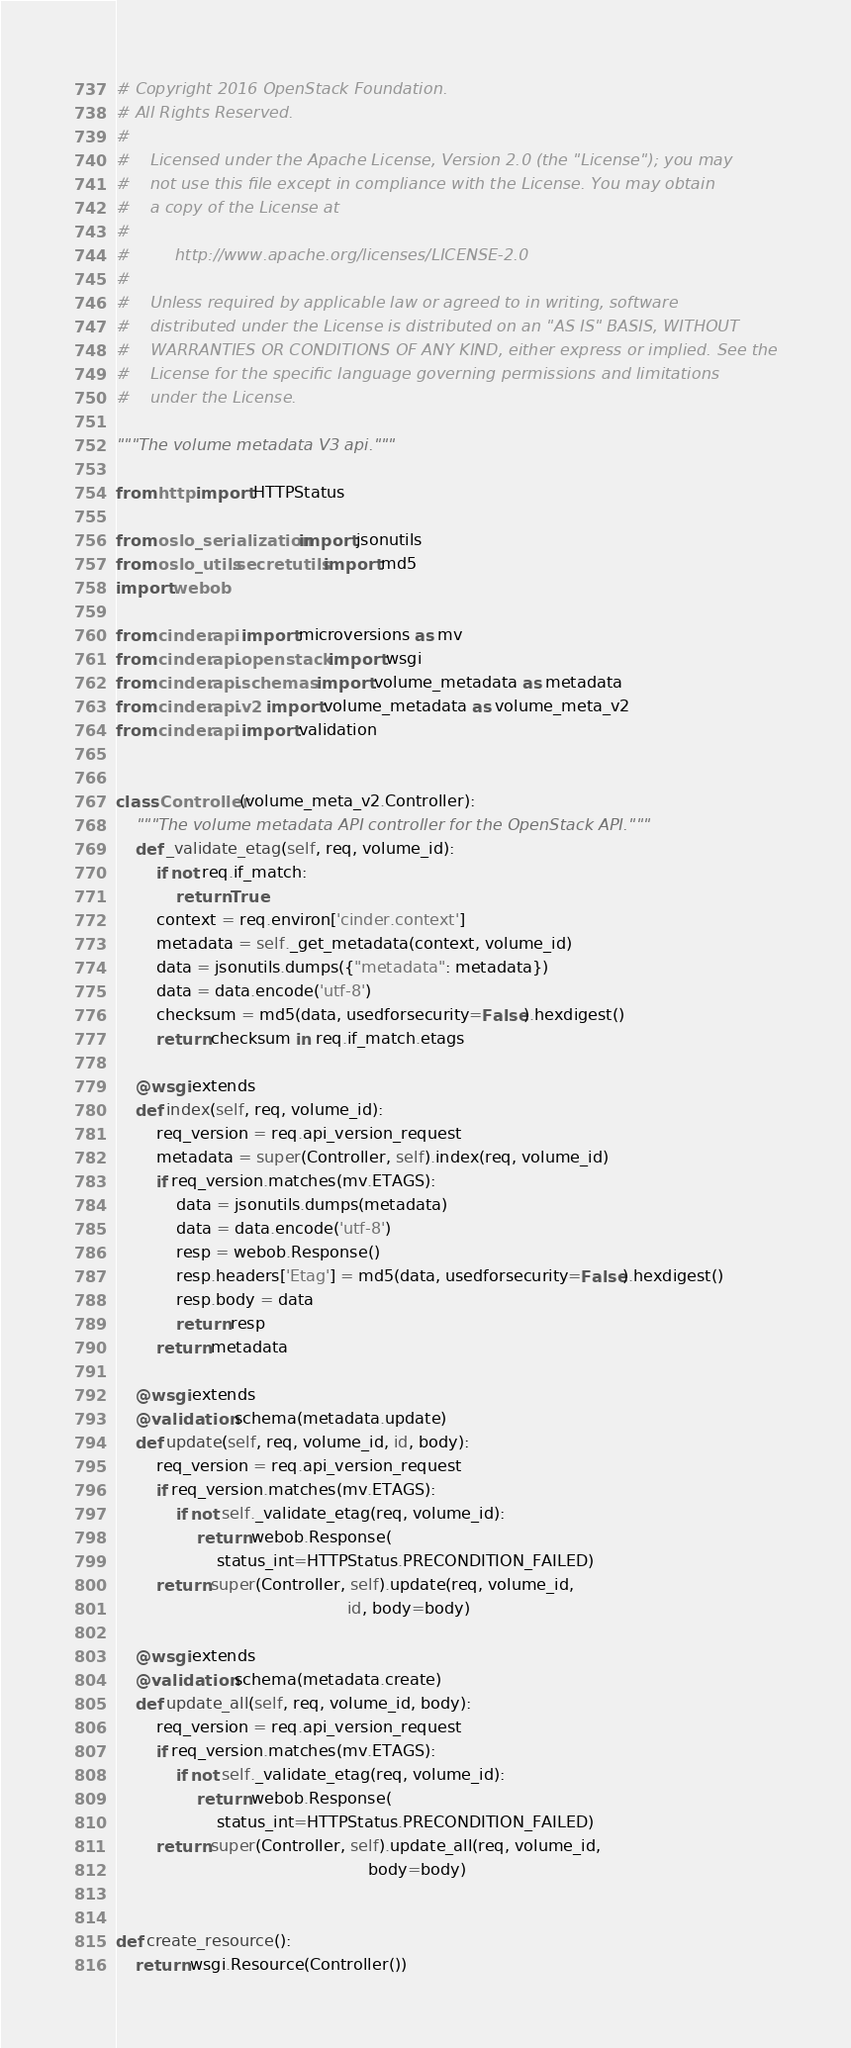Convert code to text. <code><loc_0><loc_0><loc_500><loc_500><_Python_># Copyright 2016 OpenStack Foundation.
# All Rights Reserved.
#
#    Licensed under the Apache License, Version 2.0 (the "License"); you may
#    not use this file except in compliance with the License. You may obtain
#    a copy of the License at
#
#         http://www.apache.org/licenses/LICENSE-2.0
#
#    Unless required by applicable law or agreed to in writing, software
#    distributed under the License is distributed on an "AS IS" BASIS, WITHOUT
#    WARRANTIES OR CONDITIONS OF ANY KIND, either express or implied. See the
#    License for the specific language governing permissions and limitations
#    under the License.

"""The volume metadata V3 api."""

from http import HTTPStatus

from oslo_serialization import jsonutils
from oslo_utils.secretutils import md5
import webob

from cinder.api import microversions as mv
from cinder.api.openstack import wsgi
from cinder.api.schemas import volume_metadata as metadata
from cinder.api.v2 import volume_metadata as volume_meta_v2
from cinder.api import validation


class Controller(volume_meta_v2.Controller):
    """The volume metadata API controller for the OpenStack API."""
    def _validate_etag(self, req, volume_id):
        if not req.if_match:
            return True
        context = req.environ['cinder.context']
        metadata = self._get_metadata(context, volume_id)
        data = jsonutils.dumps({"metadata": metadata})
        data = data.encode('utf-8')
        checksum = md5(data, usedforsecurity=False).hexdigest()
        return checksum in req.if_match.etags

    @wsgi.extends
    def index(self, req, volume_id):
        req_version = req.api_version_request
        metadata = super(Controller, self).index(req, volume_id)
        if req_version.matches(mv.ETAGS):
            data = jsonutils.dumps(metadata)
            data = data.encode('utf-8')
            resp = webob.Response()
            resp.headers['Etag'] = md5(data, usedforsecurity=False).hexdigest()
            resp.body = data
            return resp
        return metadata

    @wsgi.extends
    @validation.schema(metadata.update)
    def update(self, req, volume_id, id, body):
        req_version = req.api_version_request
        if req_version.matches(mv.ETAGS):
            if not self._validate_etag(req, volume_id):
                return webob.Response(
                    status_int=HTTPStatus.PRECONDITION_FAILED)
        return super(Controller, self).update(req, volume_id,
                                              id, body=body)

    @wsgi.extends
    @validation.schema(metadata.create)
    def update_all(self, req, volume_id, body):
        req_version = req.api_version_request
        if req_version.matches(mv.ETAGS):
            if not self._validate_etag(req, volume_id):
                return webob.Response(
                    status_int=HTTPStatus.PRECONDITION_FAILED)
        return super(Controller, self).update_all(req, volume_id,
                                                  body=body)


def create_resource():
    return wsgi.Resource(Controller())
</code> 